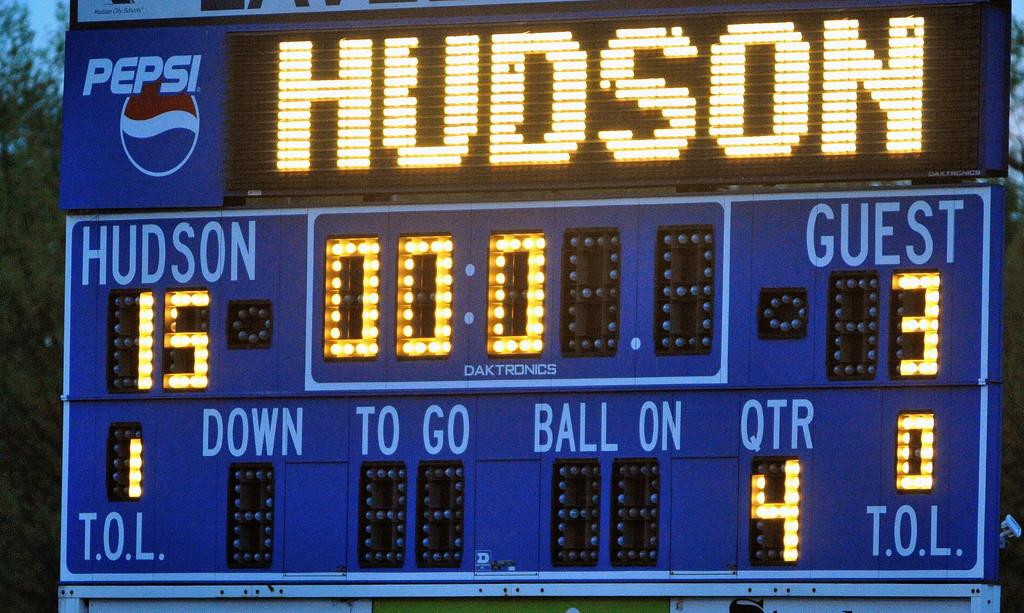<image>
Present a compact description of the photo's key features. a scoreboard with the name Hudson on it 